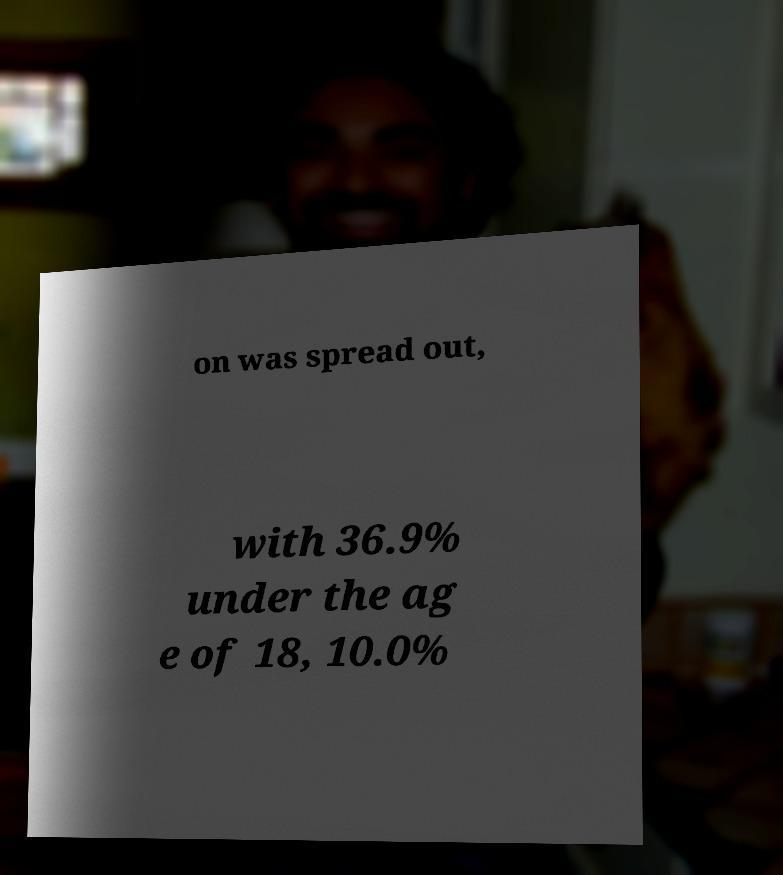There's text embedded in this image that I need extracted. Can you transcribe it verbatim? on was spread out, with 36.9% under the ag e of 18, 10.0% 